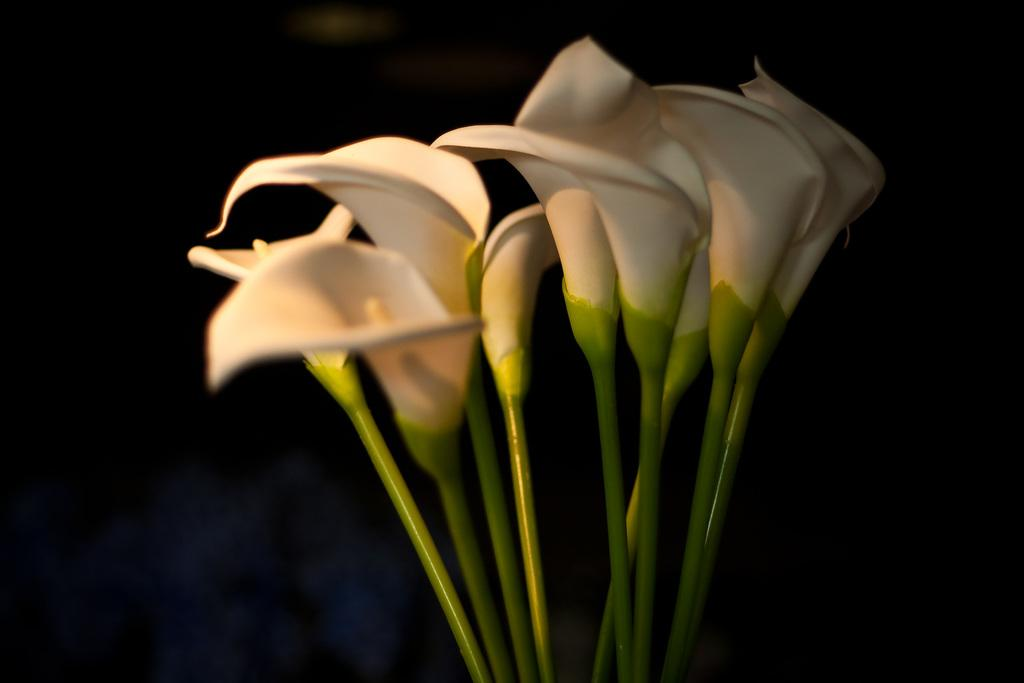What type of living organisms can be seen in the image? There are flowers in the image. How many feet can be seen on the dog in the image? There is no dog present in the image, so it is not possible to determine the number of feet on a dog. 